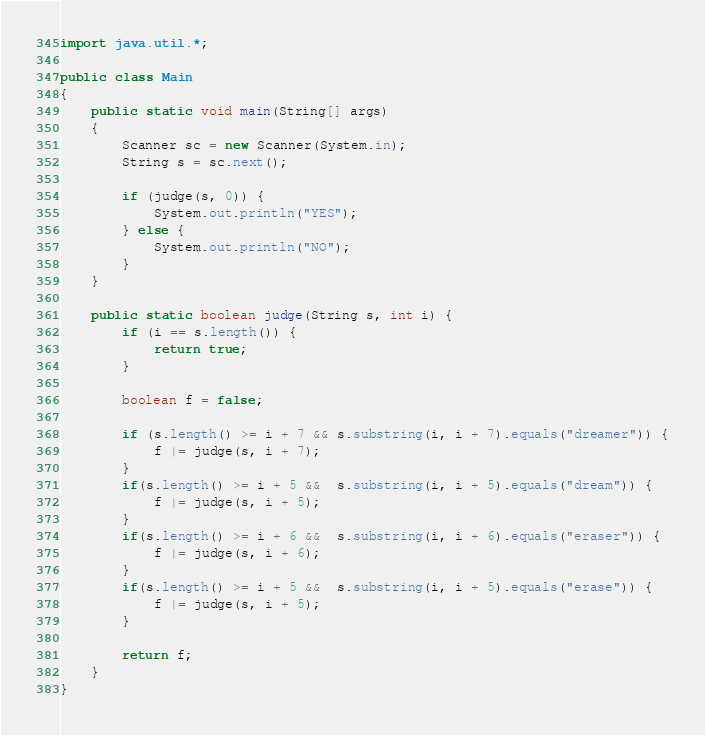<code> <loc_0><loc_0><loc_500><loc_500><_Java_>import java.util.*;

public class Main
{
	public static void main(String[] args)
	{
		Scanner sc = new Scanner(System.in);
		String s = sc.next();
		
		if (judge(s, 0)) {
			System.out.println("YES");
		} else {
			System.out.println("NO");
		}
	}
	
	public static boolean judge(String s, int i) {
		if (i == s.length()) {
			return true;
		}
		
		boolean f = false;
		
		if (s.length() >= i + 7 && s.substring(i, i + 7).equals("dreamer")) {
			f |= judge(s, i + 7);
		} 
		if(s.length() >= i + 5 &&  s.substring(i, i + 5).equals("dream")) {
			f |= judge(s, i + 5);
		} 
		if(s.length() >= i + 6 &&  s.substring(i, i + 6).equals("eraser")) {
			f |= judge(s, i + 6);
		} 
		if(s.length() >= i + 5 &&  s.substring(i, i + 5).equals("erase")) {
			f |= judge(s, i + 5);
		} 
		
		return f;
	}
}</code> 